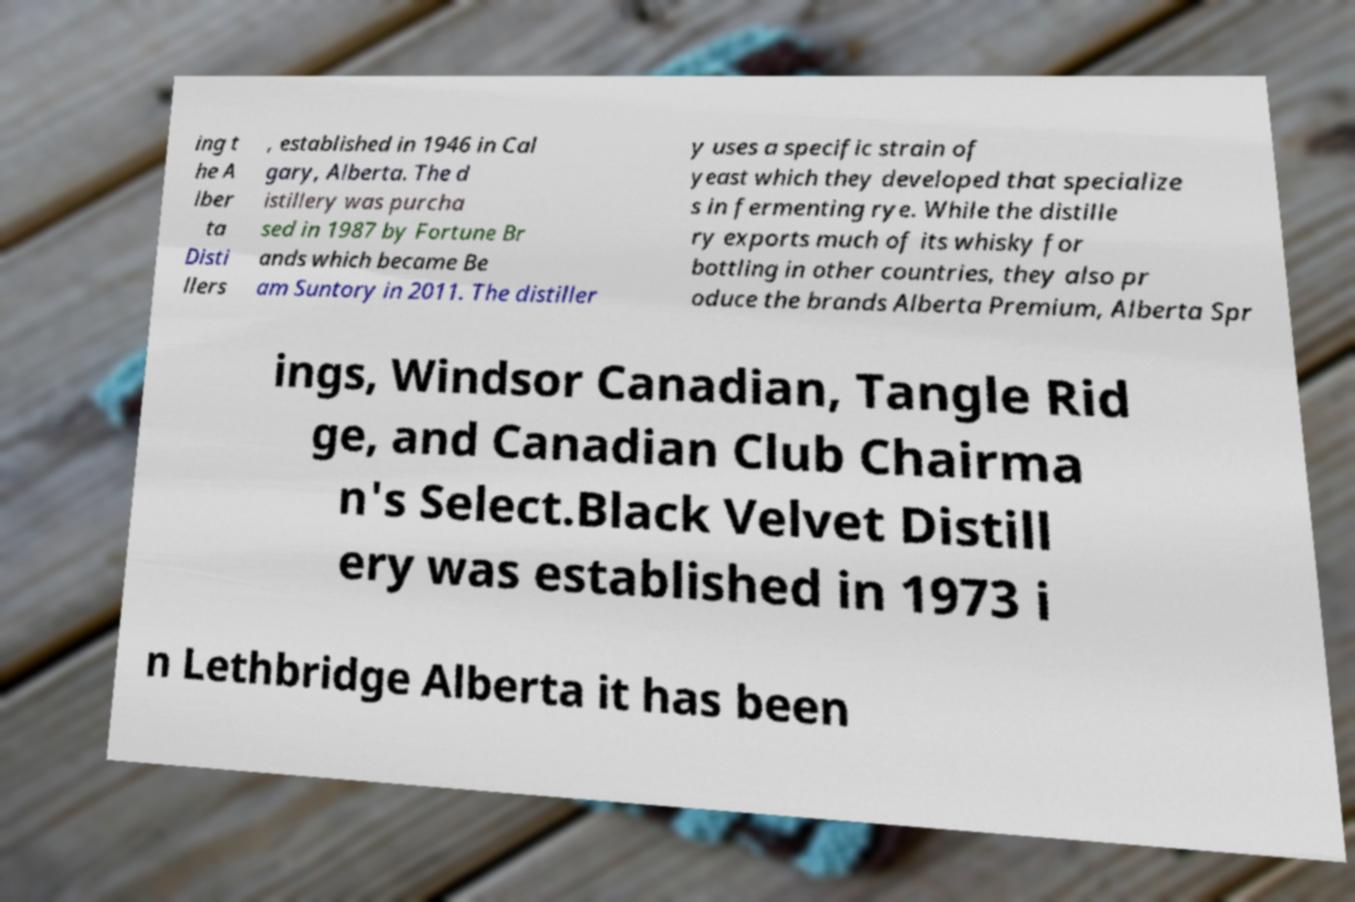What messages or text are displayed in this image? I need them in a readable, typed format. ing t he A lber ta Disti llers , established in 1946 in Cal gary, Alberta. The d istillery was purcha sed in 1987 by Fortune Br ands which became Be am Suntory in 2011. The distiller y uses a specific strain of yeast which they developed that specialize s in fermenting rye. While the distille ry exports much of its whisky for bottling in other countries, they also pr oduce the brands Alberta Premium, Alberta Spr ings, Windsor Canadian, Tangle Rid ge, and Canadian Club Chairma n's Select.Black Velvet Distill ery was established in 1973 i n Lethbridge Alberta it has been 